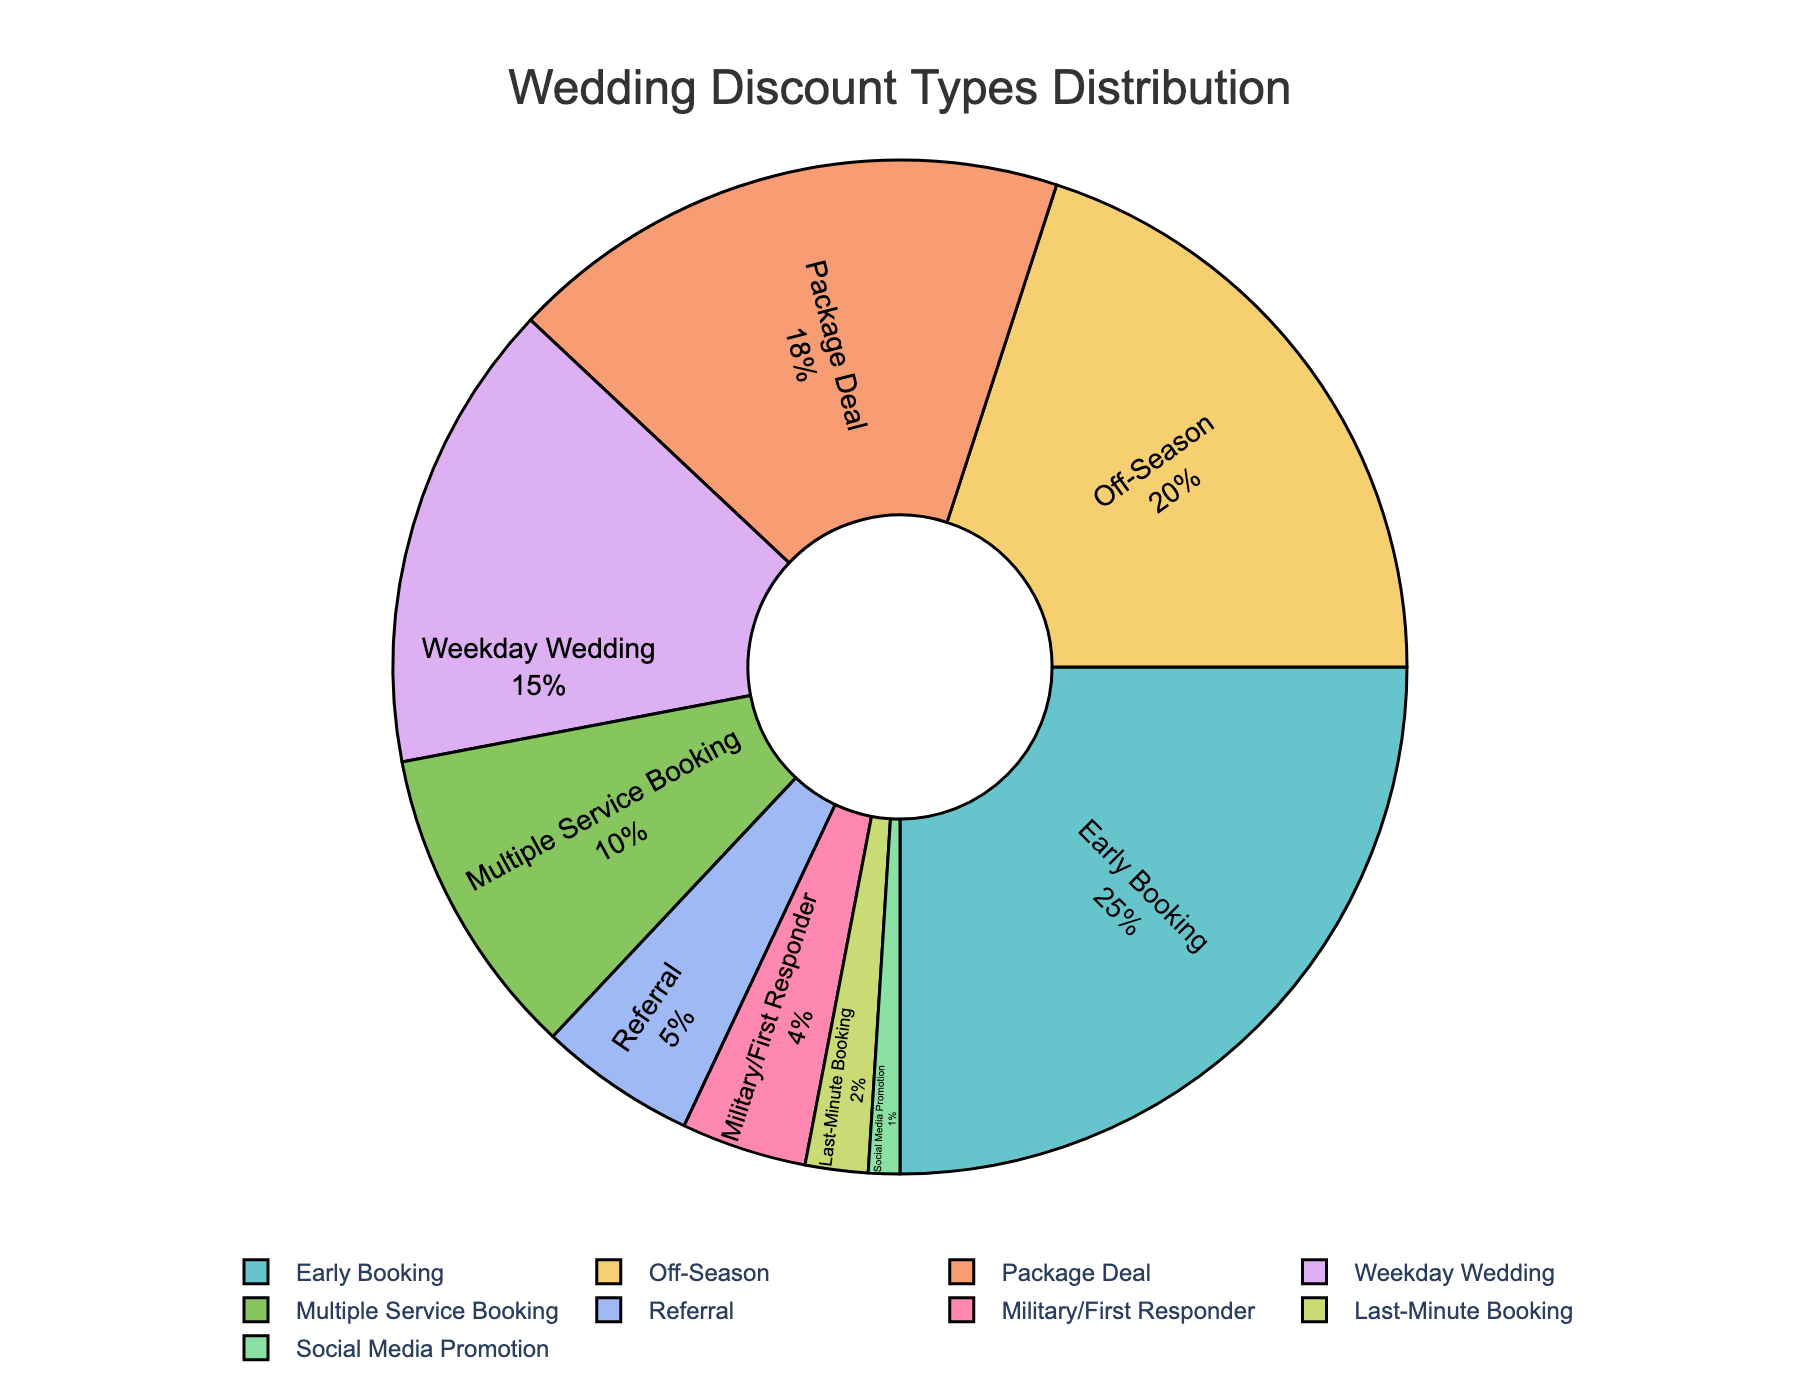what is the most common discount type offered to wedding clients in the chart? The most common discount type is the one with the largest percentage slice in the pie chart, which is the "Early Booking" discount with 25%.
Answer: Early Booking Which two discount types have the smallest proportions in the pie chart? Identify the slices with the smallest percentages, which are "Last-Minute Booking" with 2% and "Social Media Promotion" with 1%.
Answer: Last-Minute Booking and Social Media Promotion What is the combined percentage of the 'Off-Season' and 'Package Deal' discounts? Add the percentages of 'Off-Season' and 'Package Deal', which are 20% and 18% respectively: 20% + 18% = 38%.
Answer: 38% Is the 'Weekday Wedding' discount more popular than the 'Multiple Service Booking' discount? Compare the percentages of 'Weekday Wedding' (15%) and 'Multiple Service Booking' (10%). The 'Weekday Wedding' discount is more popular.
Answer: Yes How much larger is the 'Early Booking' discount compared to the 'Referral' discount? Subtract the percentage of the 'Referral' discount from the 'Early Booking' discount: 25% - 5% = 20%. The 'Early Booking' discount is 20% larger.
Answer: 20% Which discount type is represented by a blue color in the pie chart? While the exact visual may vary, assume the 'Weekday Wedding' discount is shown in blue as it is common in such palettes. Verify by looking at the legend and comparing slices.
Answer: Weekday Wedding Are the 'Military/First Responder' and 'Last-Minute Booking' discounts collectively less than the 'Off-Season' discount? Sum the percentages of 'Military/First Responder' and 'Last-Minute Booking' (4% + 2% = 6%) and compare it to the 'Off-Season' discount (20%). Their combined percentage is less than the 'Off-Season' discount.
Answer: Yes What is the difference in percentage between the 'Multiple Service Booking' and 'Social Media Promotion' discounts? Subtract the percentage of 'Social Media Promotion' from 'Multiple Service Booking': 10% - 1% = 9%. The difference is 9%.
Answer: 9% How does the 'Early Booking' discount compare to the combined percentage of the 'Military/First Responder' and 'Referral' discounts? Add the percentages of 'Military/First Responder' and 'Referral': 4% + 5% = 9% and compare it to 25%. 'Early Booking' (25%) is significantly higher.
Answer: Higher What is the average percentage of discounts in the chart? Sum all the percentages and divide by the number of discount types: (25% + 20% + 18% + 15% + 10% + 5% + 4% + 2% + 1%) / 9 ≈ 11.11%.
Answer: 11.11% 